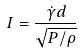Convert formula to latex. <formula><loc_0><loc_0><loc_500><loc_500>I = \frac { \dot { \gamma } d } { \sqrt { P / \rho } }</formula> 